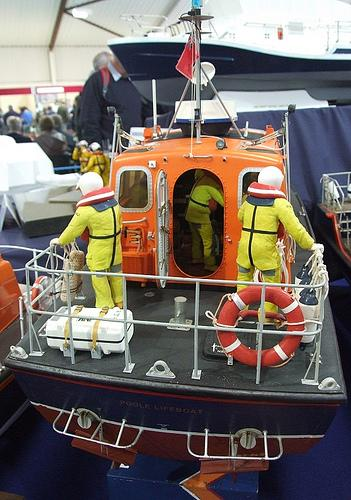Who are the men wearing yellow? Please explain your reasoning. crew. The men wearing yellow are part of the boat crew. 